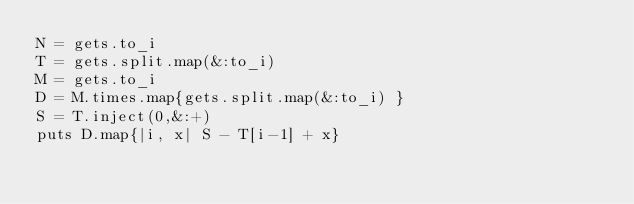<code> <loc_0><loc_0><loc_500><loc_500><_Ruby_>N = gets.to_i
T = gets.split.map(&:to_i)
M = gets.to_i
D = M.times.map{gets.split.map(&:to_i) }
S = T.inject(0,&:+)
puts D.map{|i, x| S - T[i-1] + x}</code> 